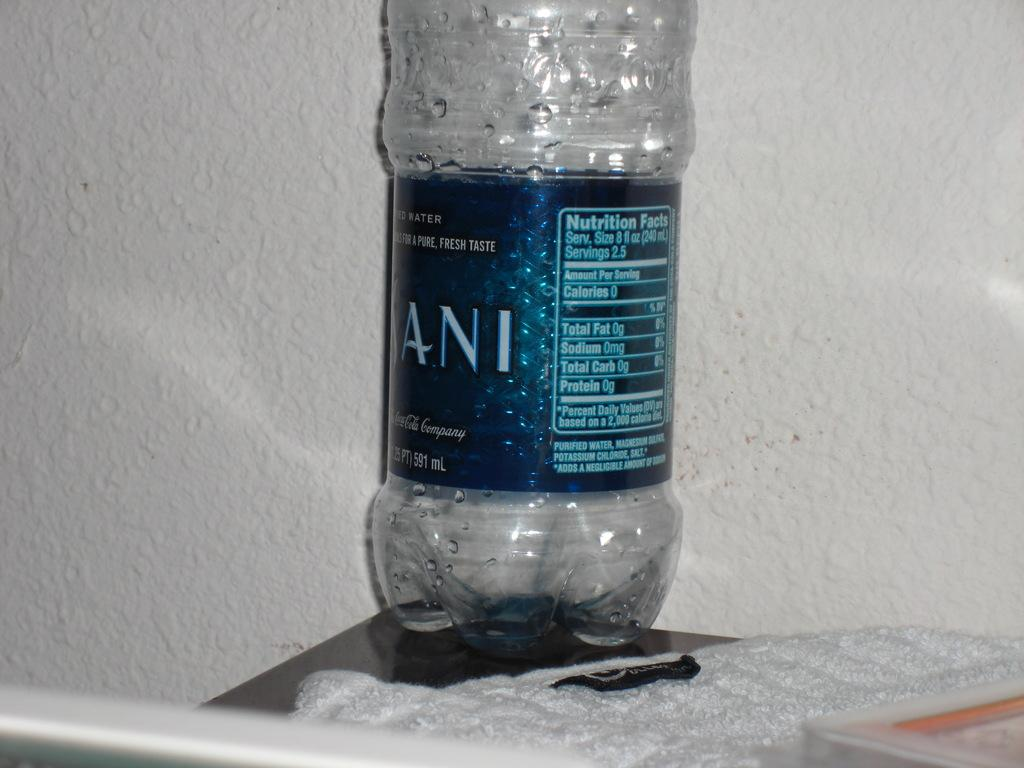What object can be seen in the image? There is a bottle in the image. What piece of furniture is present in the image? There is a table in the image. What type of material is visible in the image? There is cloth visible in the image. What can be seen in the background of the image? There is a wall in the background of the image. How many sheep are visible in the image? There are no sheep present in the image. What type of grain can be seen growing on the table in the image? There is no grain visible on the table in the image; it is a cloth-covered surface. 